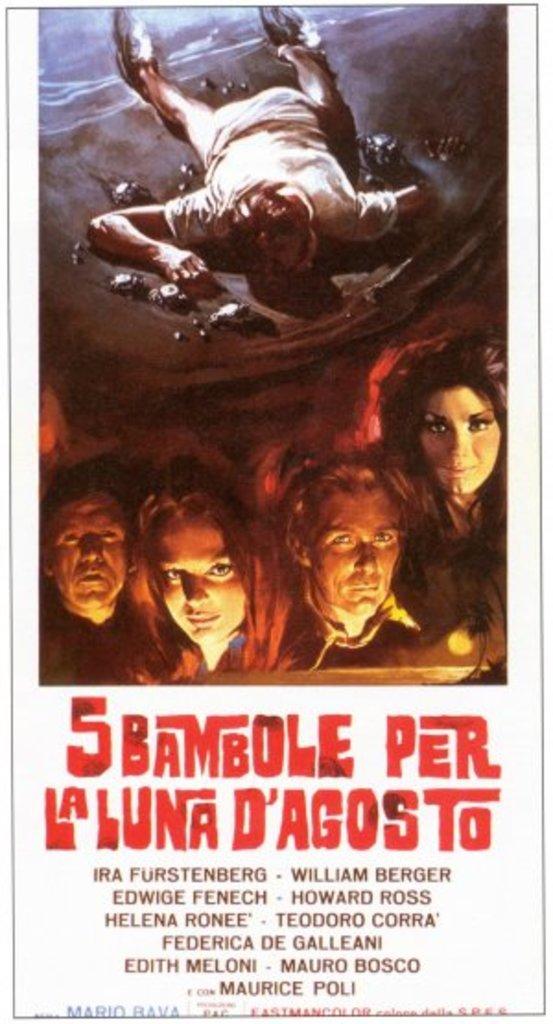What is this poster supposed to be for?
Provide a succinct answer. 5 bambole per la luna d'agosto. What is the last name on the bottom of the poster?
Your answer should be compact. Maurice poli. 